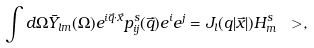<formula> <loc_0><loc_0><loc_500><loc_500>\int d \Omega \bar { Y } _ { l m } ( \Omega ) e ^ { i \vec { q } \cdot \vec { x } } p ^ { s } _ { i j } ( \vec { q } ) e ^ { i } e ^ { j } = J _ { l } ( q | \vec { x } | ) H ^ { s } _ { m } \ > ,</formula> 